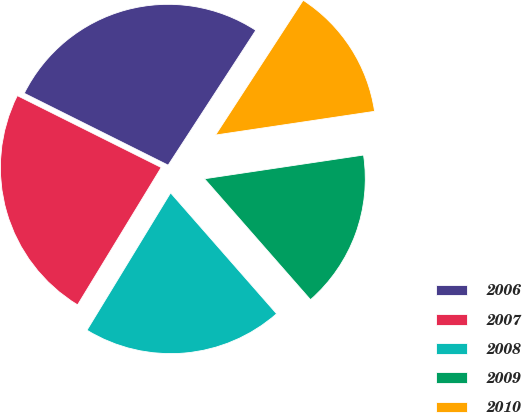Convert chart to OTSL. <chart><loc_0><loc_0><loc_500><loc_500><pie_chart><fcel>2006<fcel>2007<fcel>2008<fcel>2009<fcel>2010<nl><fcel>26.8%<fcel>23.67%<fcel>20.16%<fcel>15.9%<fcel>13.47%<nl></chart> 